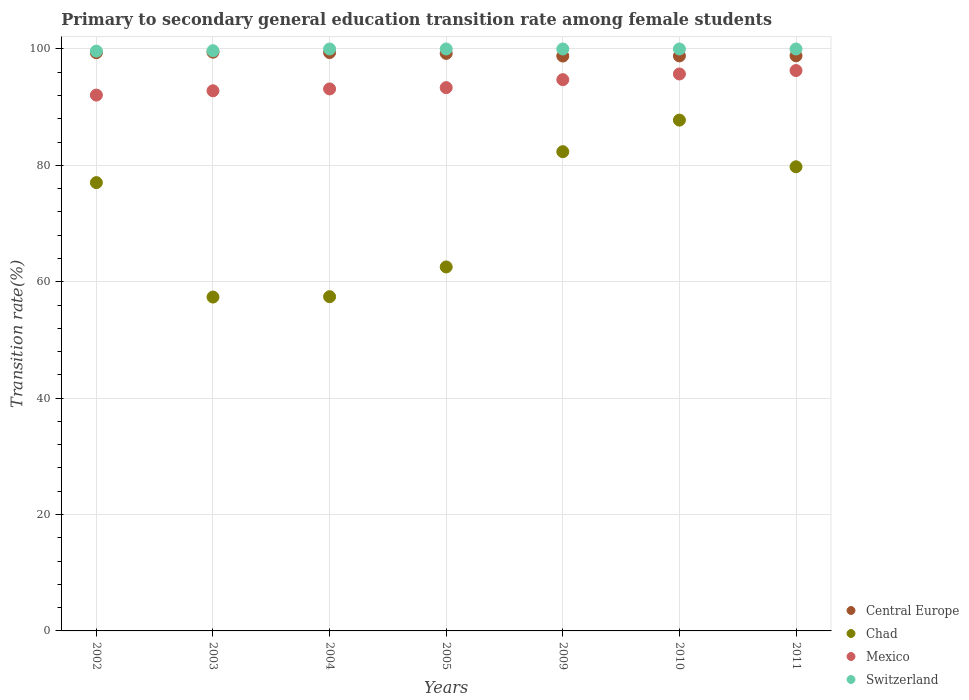Across all years, what is the maximum transition rate in Chad?
Give a very brief answer. 87.78. Across all years, what is the minimum transition rate in Chad?
Provide a succinct answer. 57.37. What is the total transition rate in Mexico in the graph?
Provide a short and direct response. 658.12. What is the difference between the transition rate in Central Europe in 2004 and that in 2010?
Provide a succinct answer. 0.58. What is the difference between the transition rate in Central Europe in 2011 and the transition rate in Switzerland in 2010?
Give a very brief answer. -1.18. What is the average transition rate in Mexico per year?
Provide a succinct answer. 94.02. In the year 2005, what is the difference between the transition rate in Central Europe and transition rate in Switzerland?
Make the answer very short. -0.76. What is the ratio of the transition rate in Chad in 2004 to that in 2005?
Keep it short and to the point. 0.92. Is the transition rate in Central Europe in 2005 less than that in 2010?
Make the answer very short. No. Is the difference between the transition rate in Central Europe in 2003 and 2004 greater than the difference between the transition rate in Switzerland in 2003 and 2004?
Offer a terse response. Yes. What is the difference between the highest and the lowest transition rate in Mexico?
Your response must be concise. 4.22. Is the sum of the transition rate in Switzerland in 2004 and 2011 greater than the maximum transition rate in Central Europe across all years?
Ensure brevity in your answer.  Yes. Is it the case that in every year, the sum of the transition rate in Central Europe and transition rate in Switzerland  is greater than the transition rate in Chad?
Your answer should be compact. Yes. How many dotlines are there?
Ensure brevity in your answer.  4. What is the difference between two consecutive major ticks on the Y-axis?
Offer a terse response. 20. Are the values on the major ticks of Y-axis written in scientific E-notation?
Give a very brief answer. No. Does the graph contain any zero values?
Ensure brevity in your answer.  No. Where does the legend appear in the graph?
Give a very brief answer. Bottom right. How many legend labels are there?
Make the answer very short. 4. How are the legend labels stacked?
Provide a succinct answer. Vertical. What is the title of the graph?
Ensure brevity in your answer.  Primary to secondary general education transition rate among female students. Does "Nepal" appear as one of the legend labels in the graph?
Provide a succinct answer. No. What is the label or title of the X-axis?
Make the answer very short. Years. What is the label or title of the Y-axis?
Give a very brief answer. Transition rate(%). What is the Transition rate(%) of Central Europe in 2002?
Your answer should be very brief. 99.36. What is the Transition rate(%) of Chad in 2002?
Make the answer very short. 77.03. What is the Transition rate(%) of Mexico in 2002?
Your response must be concise. 92.08. What is the Transition rate(%) in Switzerland in 2002?
Provide a short and direct response. 99.64. What is the Transition rate(%) of Central Europe in 2003?
Your answer should be very brief. 99.45. What is the Transition rate(%) of Chad in 2003?
Provide a succinct answer. 57.37. What is the Transition rate(%) of Mexico in 2003?
Your answer should be compact. 92.82. What is the Transition rate(%) in Switzerland in 2003?
Your answer should be compact. 99.7. What is the Transition rate(%) of Central Europe in 2004?
Give a very brief answer. 99.38. What is the Transition rate(%) of Chad in 2004?
Offer a terse response. 57.43. What is the Transition rate(%) of Mexico in 2004?
Offer a very short reply. 93.14. What is the Transition rate(%) of Central Europe in 2005?
Keep it short and to the point. 99.24. What is the Transition rate(%) in Chad in 2005?
Give a very brief answer. 62.54. What is the Transition rate(%) of Mexico in 2005?
Provide a short and direct response. 93.36. What is the Transition rate(%) of Switzerland in 2005?
Your response must be concise. 100. What is the Transition rate(%) in Central Europe in 2009?
Provide a short and direct response. 98.78. What is the Transition rate(%) in Chad in 2009?
Your answer should be compact. 82.35. What is the Transition rate(%) in Mexico in 2009?
Keep it short and to the point. 94.73. What is the Transition rate(%) in Switzerland in 2009?
Your response must be concise. 100. What is the Transition rate(%) in Central Europe in 2010?
Offer a terse response. 98.81. What is the Transition rate(%) in Chad in 2010?
Your answer should be compact. 87.78. What is the Transition rate(%) in Mexico in 2010?
Give a very brief answer. 95.71. What is the Transition rate(%) in Central Europe in 2011?
Keep it short and to the point. 98.82. What is the Transition rate(%) in Chad in 2011?
Keep it short and to the point. 79.76. What is the Transition rate(%) in Mexico in 2011?
Provide a succinct answer. 96.29. What is the Transition rate(%) of Switzerland in 2011?
Your response must be concise. 100. Across all years, what is the maximum Transition rate(%) of Central Europe?
Ensure brevity in your answer.  99.45. Across all years, what is the maximum Transition rate(%) of Chad?
Your response must be concise. 87.78. Across all years, what is the maximum Transition rate(%) in Mexico?
Ensure brevity in your answer.  96.29. Across all years, what is the minimum Transition rate(%) of Central Europe?
Keep it short and to the point. 98.78. Across all years, what is the minimum Transition rate(%) in Chad?
Provide a succinct answer. 57.37. Across all years, what is the minimum Transition rate(%) in Mexico?
Give a very brief answer. 92.08. Across all years, what is the minimum Transition rate(%) of Switzerland?
Your answer should be very brief. 99.64. What is the total Transition rate(%) of Central Europe in the graph?
Keep it short and to the point. 693.85. What is the total Transition rate(%) of Chad in the graph?
Offer a very short reply. 504.27. What is the total Transition rate(%) in Mexico in the graph?
Ensure brevity in your answer.  658.12. What is the total Transition rate(%) in Switzerland in the graph?
Give a very brief answer. 699.34. What is the difference between the Transition rate(%) in Central Europe in 2002 and that in 2003?
Offer a terse response. -0.09. What is the difference between the Transition rate(%) of Chad in 2002 and that in 2003?
Your answer should be compact. 19.66. What is the difference between the Transition rate(%) of Mexico in 2002 and that in 2003?
Make the answer very short. -0.74. What is the difference between the Transition rate(%) in Switzerland in 2002 and that in 2003?
Make the answer very short. -0.07. What is the difference between the Transition rate(%) in Central Europe in 2002 and that in 2004?
Make the answer very short. -0.02. What is the difference between the Transition rate(%) of Chad in 2002 and that in 2004?
Keep it short and to the point. 19.6. What is the difference between the Transition rate(%) of Mexico in 2002 and that in 2004?
Provide a short and direct response. -1.06. What is the difference between the Transition rate(%) of Switzerland in 2002 and that in 2004?
Provide a short and direct response. -0.36. What is the difference between the Transition rate(%) in Central Europe in 2002 and that in 2005?
Make the answer very short. 0.12. What is the difference between the Transition rate(%) in Chad in 2002 and that in 2005?
Ensure brevity in your answer.  14.49. What is the difference between the Transition rate(%) in Mexico in 2002 and that in 2005?
Give a very brief answer. -1.28. What is the difference between the Transition rate(%) of Switzerland in 2002 and that in 2005?
Provide a short and direct response. -0.36. What is the difference between the Transition rate(%) in Central Europe in 2002 and that in 2009?
Offer a terse response. 0.58. What is the difference between the Transition rate(%) of Chad in 2002 and that in 2009?
Offer a terse response. -5.32. What is the difference between the Transition rate(%) in Mexico in 2002 and that in 2009?
Make the answer very short. -2.65. What is the difference between the Transition rate(%) in Switzerland in 2002 and that in 2009?
Your answer should be very brief. -0.36. What is the difference between the Transition rate(%) in Central Europe in 2002 and that in 2010?
Offer a terse response. 0.56. What is the difference between the Transition rate(%) of Chad in 2002 and that in 2010?
Offer a very short reply. -10.74. What is the difference between the Transition rate(%) of Mexico in 2002 and that in 2010?
Keep it short and to the point. -3.63. What is the difference between the Transition rate(%) of Switzerland in 2002 and that in 2010?
Your response must be concise. -0.36. What is the difference between the Transition rate(%) of Central Europe in 2002 and that in 2011?
Your answer should be very brief. 0.54. What is the difference between the Transition rate(%) in Chad in 2002 and that in 2011?
Your answer should be compact. -2.72. What is the difference between the Transition rate(%) in Mexico in 2002 and that in 2011?
Your answer should be very brief. -4.22. What is the difference between the Transition rate(%) in Switzerland in 2002 and that in 2011?
Make the answer very short. -0.36. What is the difference between the Transition rate(%) of Central Europe in 2003 and that in 2004?
Ensure brevity in your answer.  0.07. What is the difference between the Transition rate(%) of Chad in 2003 and that in 2004?
Provide a short and direct response. -0.06. What is the difference between the Transition rate(%) of Mexico in 2003 and that in 2004?
Offer a terse response. -0.32. What is the difference between the Transition rate(%) of Switzerland in 2003 and that in 2004?
Your answer should be compact. -0.3. What is the difference between the Transition rate(%) of Central Europe in 2003 and that in 2005?
Your answer should be very brief. 0.21. What is the difference between the Transition rate(%) of Chad in 2003 and that in 2005?
Your answer should be very brief. -5.17. What is the difference between the Transition rate(%) in Mexico in 2003 and that in 2005?
Your answer should be very brief. -0.54. What is the difference between the Transition rate(%) of Switzerland in 2003 and that in 2005?
Offer a very short reply. -0.3. What is the difference between the Transition rate(%) in Central Europe in 2003 and that in 2009?
Ensure brevity in your answer.  0.67. What is the difference between the Transition rate(%) in Chad in 2003 and that in 2009?
Offer a terse response. -24.98. What is the difference between the Transition rate(%) in Mexico in 2003 and that in 2009?
Offer a terse response. -1.91. What is the difference between the Transition rate(%) of Switzerland in 2003 and that in 2009?
Provide a succinct answer. -0.3. What is the difference between the Transition rate(%) in Central Europe in 2003 and that in 2010?
Keep it short and to the point. 0.65. What is the difference between the Transition rate(%) in Chad in 2003 and that in 2010?
Your response must be concise. -30.41. What is the difference between the Transition rate(%) in Mexico in 2003 and that in 2010?
Offer a very short reply. -2.89. What is the difference between the Transition rate(%) of Switzerland in 2003 and that in 2010?
Keep it short and to the point. -0.3. What is the difference between the Transition rate(%) in Central Europe in 2003 and that in 2011?
Ensure brevity in your answer.  0.63. What is the difference between the Transition rate(%) in Chad in 2003 and that in 2011?
Offer a very short reply. -22.38. What is the difference between the Transition rate(%) of Mexico in 2003 and that in 2011?
Ensure brevity in your answer.  -3.48. What is the difference between the Transition rate(%) in Switzerland in 2003 and that in 2011?
Your answer should be very brief. -0.3. What is the difference between the Transition rate(%) in Central Europe in 2004 and that in 2005?
Your answer should be very brief. 0.14. What is the difference between the Transition rate(%) of Chad in 2004 and that in 2005?
Offer a very short reply. -5.11. What is the difference between the Transition rate(%) of Mexico in 2004 and that in 2005?
Make the answer very short. -0.22. What is the difference between the Transition rate(%) in Central Europe in 2004 and that in 2009?
Give a very brief answer. 0.6. What is the difference between the Transition rate(%) in Chad in 2004 and that in 2009?
Your response must be concise. -24.92. What is the difference between the Transition rate(%) in Mexico in 2004 and that in 2009?
Provide a succinct answer. -1.59. What is the difference between the Transition rate(%) in Switzerland in 2004 and that in 2009?
Your answer should be compact. 0. What is the difference between the Transition rate(%) in Central Europe in 2004 and that in 2010?
Make the answer very short. 0.58. What is the difference between the Transition rate(%) in Chad in 2004 and that in 2010?
Provide a succinct answer. -30.34. What is the difference between the Transition rate(%) of Mexico in 2004 and that in 2010?
Ensure brevity in your answer.  -2.57. What is the difference between the Transition rate(%) of Switzerland in 2004 and that in 2010?
Provide a succinct answer. 0. What is the difference between the Transition rate(%) of Central Europe in 2004 and that in 2011?
Keep it short and to the point. 0.56. What is the difference between the Transition rate(%) of Chad in 2004 and that in 2011?
Make the answer very short. -22.32. What is the difference between the Transition rate(%) in Mexico in 2004 and that in 2011?
Offer a terse response. -3.16. What is the difference between the Transition rate(%) in Central Europe in 2005 and that in 2009?
Your answer should be very brief. 0.46. What is the difference between the Transition rate(%) in Chad in 2005 and that in 2009?
Offer a terse response. -19.81. What is the difference between the Transition rate(%) of Mexico in 2005 and that in 2009?
Give a very brief answer. -1.37. What is the difference between the Transition rate(%) of Central Europe in 2005 and that in 2010?
Provide a short and direct response. 0.44. What is the difference between the Transition rate(%) in Chad in 2005 and that in 2010?
Give a very brief answer. -25.23. What is the difference between the Transition rate(%) in Mexico in 2005 and that in 2010?
Your response must be concise. -2.35. What is the difference between the Transition rate(%) of Central Europe in 2005 and that in 2011?
Offer a terse response. 0.42. What is the difference between the Transition rate(%) of Chad in 2005 and that in 2011?
Give a very brief answer. -17.21. What is the difference between the Transition rate(%) of Mexico in 2005 and that in 2011?
Make the answer very short. -2.94. What is the difference between the Transition rate(%) of Central Europe in 2009 and that in 2010?
Give a very brief answer. -0.02. What is the difference between the Transition rate(%) of Chad in 2009 and that in 2010?
Ensure brevity in your answer.  -5.42. What is the difference between the Transition rate(%) in Mexico in 2009 and that in 2010?
Offer a terse response. -0.98. What is the difference between the Transition rate(%) of Central Europe in 2009 and that in 2011?
Offer a very short reply. -0.04. What is the difference between the Transition rate(%) in Chad in 2009 and that in 2011?
Your response must be concise. 2.6. What is the difference between the Transition rate(%) of Mexico in 2009 and that in 2011?
Provide a short and direct response. -1.56. What is the difference between the Transition rate(%) of Switzerland in 2009 and that in 2011?
Provide a succinct answer. 0. What is the difference between the Transition rate(%) of Central Europe in 2010 and that in 2011?
Your response must be concise. -0.02. What is the difference between the Transition rate(%) of Chad in 2010 and that in 2011?
Provide a short and direct response. 8.02. What is the difference between the Transition rate(%) in Mexico in 2010 and that in 2011?
Your answer should be very brief. -0.59. What is the difference between the Transition rate(%) in Switzerland in 2010 and that in 2011?
Offer a very short reply. 0. What is the difference between the Transition rate(%) in Central Europe in 2002 and the Transition rate(%) in Chad in 2003?
Ensure brevity in your answer.  41.99. What is the difference between the Transition rate(%) in Central Europe in 2002 and the Transition rate(%) in Mexico in 2003?
Provide a succinct answer. 6.55. What is the difference between the Transition rate(%) of Central Europe in 2002 and the Transition rate(%) of Switzerland in 2003?
Your response must be concise. -0.34. What is the difference between the Transition rate(%) in Chad in 2002 and the Transition rate(%) in Mexico in 2003?
Your answer should be compact. -15.78. What is the difference between the Transition rate(%) in Chad in 2002 and the Transition rate(%) in Switzerland in 2003?
Your response must be concise. -22.67. What is the difference between the Transition rate(%) of Mexico in 2002 and the Transition rate(%) of Switzerland in 2003?
Make the answer very short. -7.62. What is the difference between the Transition rate(%) of Central Europe in 2002 and the Transition rate(%) of Chad in 2004?
Offer a terse response. 41.93. What is the difference between the Transition rate(%) in Central Europe in 2002 and the Transition rate(%) in Mexico in 2004?
Provide a short and direct response. 6.23. What is the difference between the Transition rate(%) of Central Europe in 2002 and the Transition rate(%) of Switzerland in 2004?
Ensure brevity in your answer.  -0.64. What is the difference between the Transition rate(%) in Chad in 2002 and the Transition rate(%) in Mexico in 2004?
Offer a terse response. -16.1. What is the difference between the Transition rate(%) of Chad in 2002 and the Transition rate(%) of Switzerland in 2004?
Offer a very short reply. -22.97. What is the difference between the Transition rate(%) in Mexico in 2002 and the Transition rate(%) in Switzerland in 2004?
Offer a terse response. -7.92. What is the difference between the Transition rate(%) in Central Europe in 2002 and the Transition rate(%) in Chad in 2005?
Make the answer very short. 36.82. What is the difference between the Transition rate(%) of Central Europe in 2002 and the Transition rate(%) of Mexico in 2005?
Provide a succinct answer. 6. What is the difference between the Transition rate(%) of Central Europe in 2002 and the Transition rate(%) of Switzerland in 2005?
Provide a succinct answer. -0.64. What is the difference between the Transition rate(%) of Chad in 2002 and the Transition rate(%) of Mexico in 2005?
Your answer should be very brief. -16.32. What is the difference between the Transition rate(%) in Chad in 2002 and the Transition rate(%) in Switzerland in 2005?
Your answer should be compact. -22.97. What is the difference between the Transition rate(%) in Mexico in 2002 and the Transition rate(%) in Switzerland in 2005?
Offer a terse response. -7.92. What is the difference between the Transition rate(%) of Central Europe in 2002 and the Transition rate(%) of Chad in 2009?
Ensure brevity in your answer.  17.01. What is the difference between the Transition rate(%) in Central Europe in 2002 and the Transition rate(%) in Mexico in 2009?
Offer a terse response. 4.63. What is the difference between the Transition rate(%) in Central Europe in 2002 and the Transition rate(%) in Switzerland in 2009?
Offer a very short reply. -0.64. What is the difference between the Transition rate(%) in Chad in 2002 and the Transition rate(%) in Mexico in 2009?
Make the answer very short. -17.69. What is the difference between the Transition rate(%) in Chad in 2002 and the Transition rate(%) in Switzerland in 2009?
Offer a very short reply. -22.97. What is the difference between the Transition rate(%) of Mexico in 2002 and the Transition rate(%) of Switzerland in 2009?
Ensure brevity in your answer.  -7.92. What is the difference between the Transition rate(%) of Central Europe in 2002 and the Transition rate(%) of Chad in 2010?
Offer a terse response. 11.58. What is the difference between the Transition rate(%) in Central Europe in 2002 and the Transition rate(%) in Mexico in 2010?
Ensure brevity in your answer.  3.66. What is the difference between the Transition rate(%) of Central Europe in 2002 and the Transition rate(%) of Switzerland in 2010?
Give a very brief answer. -0.64. What is the difference between the Transition rate(%) of Chad in 2002 and the Transition rate(%) of Mexico in 2010?
Provide a short and direct response. -18.67. What is the difference between the Transition rate(%) of Chad in 2002 and the Transition rate(%) of Switzerland in 2010?
Provide a succinct answer. -22.97. What is the difference between the Transition rate(%) in Mexico in 2002 and the Transition rate(%) in Switzerland in 2010?
Ensure brevity in your answer.  -7.92. What is the difference between the Transition rate(%) in Central Europe in 2002 and the Transition rate(%) in Chad in 2011?
Your answer should be compact. 19.61. What is the difference between the Transition rate(%) in Central Europe in 2002 and the Transition rate(%) in Mexico in 2011?
Offer a very short reply. 3.07. What is the difference between the Transition rate(%) in Central Europe in 2002 and the Transition rate(%) in Switzerland in 2011?
Keep it short and to the point. -0.64. What is the difference between the Transition rate(%) of Chad in 2002 and the Transition rate(%) of Mexico in 2011?
Make the answer very short. -19.26. What is the difference between the Transition rate(%) of Chad in 2002 and the Transition rate(%) of Switzerland in 2011?
Your answer should be compact. -22.97. What is the difference between the Transition rate(%) in Mexico in 2002 and the Transition rate(%) in Switzerland in 2011?
Keep it short and to the point. -7.92. What is the difference between the Transition rate(%) in Central Europe in 2003 and the Transition rate(%) in Chad in 2004?
Ensure brevity in your answer.  42.02. What is the difference between the Transition rate(%) of Central Europe in 2003 and the Transition rate(%) of Mexico in 2004?
Give a very brief answer. 6.32. What is the difference between the Transition rate(%) in Central Europe in 2003 and the Transition rate(%) in Switzerland in 2004?
Offer a terse response. -0.55. What is the difference between the Transition rate(%) in Chad in 2003 and the Transition rate(%) in Mexico in 2004?
Offer a terse response. -35.77. What is the difference between the Transition rate(%) in Chad in 2003 and the Transition rate(%) in Switzerland in 2004?
Offer a very short reply. -42.63. What is the difference between the Transition rate(%) in Mexico in 2003 and the Transition rate(%) in Switzerland in 2004?
Your answer should be compact. -7.18. What is the difference between the Transition rate(%) in Central Europe in 2003 and the Transition rate(%) in Chad in 2005?
Your answer should be compact. 36.91. What is the difference between the Transition rate(%) in Central Europe in 2003 and the Transition rate(%) in Mexico in 2005?
Offer a very short reply. 6.1. What is the difference between the Transition rate(%) of Central Europe in 2003 and the Transition rate(%) of Switzerland in 2005?
Offer a very short reply. -0.55. What is the difference between the Transition rate(%) in Chad in 2003 and the Transition rate(%) in Mexico in 2005?
Make the answer very short. -35.99. What is the difference between the Transition rate(%) in Chad in 2003 and the Transition rate(%) in Switzerland in 2005?
Offer a terse response. -42.63. What is the difference between the Transition rate(%) of Mexico in 2003 and the Transition rate(%) of Switzerland in 2005?
Offer a very short reply. -7.18. What is the difference between the Transition rate(%) of Central Europe in 2003 and the Transition rate(%) of Chad in 2009?
Your answer should be compact. 17.1. What is the difference between the Transition rate(%) in Central Europe in 2003 and the Transition rate(%) in Mexico in 2009?
Give a very brief answer. 4.72. What is the difference between the Transition rate(%) in Central Europe in 2003 and the Transition rate(%) in Switzerland in 2009?
Your response must be concise. -0.55. What is the difference between the Transition rate(%) in Chad in 2003 and the Transition rate(%) in Mexico in 2009?
Give a very brief answer. -37.36. What is the difference between the Transition rate(%) of Chad in 2003 and the Transition rate(%) of Switzerland in 2009?
Offer a terse response. -42.63. What is the difference between the Transition rate(%) in Mexico in 2003 and the Transition rate(%) in Switzerland in 2009?
Ensure brevity in your answer.  -7.18. What is the difference between the Transition rate(%) of Central Europe in 2003 and the Transition rate(%) of Chad in 2010?
Give a very brief answer. 11.68. What is the difference between the Transition rate(%) of Central Europe in 2003 and the Transition rate(%) of Mexico in 2010?
Offer a terse response. 3.75. What is the difference between the Transition rate(%) of Central Europe in 2003 and the Transition rate(%) of Switzerland in 2010?
Ensure brevity in your answer.  -0.55. What is the difference between the Transition rate(%) in Chad in 2003 and the Transition rate(%) in Mexico in 2010?
Offer a terse response. -38.34. What is the difference between the Transition rate(%) in Chad in 2003 and the Transition rate(%) in Switzerland in 2010?
Offer a terse response. -42.63. What is the difference between the Transition rate(%) in Mexico in 2003 and the Transition rate(%) in Switzerland in 2010?
Offer a very short reply. -7.18. What is the difference between the Transition rate(%) in Central Europe in 2003 and the Transition rate(%) in Chad in 2011?
Offer a terse response. 19.7. What is the difference between the Transition rate(%) in Central Europe in 2003 and the Transition rate(%) in Mexico in 2011?
Offer a terse response. 3.16. What is the difference between the Transition rate(%) of Central Europe in 2003 and the Transition rate(%) of Switzerland in 2011?
Give a very brief answer. -0.55. What is the difference between the Transition rate(%) in Chad in 2003 and the Transition rate(%) in Mexico in 2011?
Offer a terse response. -38.92. What is the difference between the Transition rate(%) of Chad in 2003 and the Transition rate(%) of Switzerland in 2011?
Your answer should be very brief. -42.63. What is the difference between the Transition rate(%) in Mexico in 2003 and the Transition rate(%) in Switzerland in 2011?
Offer a terse response. -7.18. What is the difference between the Transition rate(%) of Central Europe in 2004 and the Transition rate(%) of Chad in 2005?
Your response must be concise. 36.84. What is the difference between the Transition rate(%) of Central Europe in 2004 and the Transition rate(%) of Mexico in 2005?
Your response must be concise. 6.02. What is the difference between the Transition rate(%) in Central Europe in 2004 and the Transition rate(%) in Switzerland in 2005?
Your response must be concise. -0.62. What is the difference between the Transition rate(%) of Chad in 2004 and the Transition rate(%) of Mexico in 2005?
Offer a terse response. -35.92. What is the difference between the Transition rate(%) in Chad in 2004 and the Transition rate(%) in Switzerland in 2005?
Ensure brevity in your answer.  -42.57. What is the difference between the Transition rate(%) in Mexico in 2004 and the Transition rate(%) in Switzerland in 2005?
Offer a very short reply. -6.86. What is the difference between the Transition rate(%) in Central Europe in 2004 and the Transition rate(%) in Chad in 2009?
Provide a short and direct response. 17.03. What is the difference between the Transition rate(%) of Central Europe in 2004 and the Transition rate(%) of Mexico in 2009?
Your response must be concise. 4.65. What is the difference between the Transition rate(%) in Central Europe in 2004 and the Transition rate(%) in Switzerland in 2009?
Your answer should be compact. -0.62. What is the difference between the Transition rate(%) in Chad in 2004 and the Transition rate(%) in Mexico in 2009?
Give a very brief answer. -37.3. What is the difference between the Transition rate(%) in Chad in 2004 and the Transition rate(%) in Switzerland in 2009?
Provide a short and direct response. -42.57. What is the difference between the Transition rate(%) in Mexico in 2004 and the Transition rate(%) in Switzerland in 2009?
Your answer should be very brief. -6.86. What is the difference between the Transition rate(%) in Central Europe in 2004 and the Transition rate(%) in Chad in 2010?
Offer a terse response. 11.6. What is the difference between the Transition rate(%) of Central Europe in 2004 and the Transition rate(%) of Mexico in 2010?
Your answer should be very brief. 3.68. What is the difference between the Transition rate(%) of Central Europe in 2004 and the Transition rate(%) of Switzerland in 2010?
Offer a terse response. -0.62. What is the difference between the Transition rate(%) in Chad in 2004 and the Transition rate(%) in Mexico in 2010?
Your answer should be compact. -38.27. What is the difference between the Transition rate(%) in Chad in 2004 and the Transition rate(%) in Switzerland in 2010?
Your answer should be compact. -42.57. What is the difference between the Transition rate(%) in Mexico in 2004 and the Transition rate(%) in Switzerland in 2010?
Your response must be concise. -6.86. What is the difference between the Transition rate(%) of Central Europe in 2004 and the Transition rate(%) of Chad in 2011?
Offer a very short reply. 19.63. What is the difference between the Transition rate(%) of Central Europe in 2004 and the Transition rate(%) of Mexico in 2011?
Make the answer very short. 3.09. What is the difference between the Transition rate(%) of Central Europe in 2004 and the Transition rate(%) of Switzerland in 2011?
Ensure brevity in your answer.  -0.62. What is the difference between the Transition rate(%) in Chad in 2004 and the Transition rate(%) in Mexico in 2011?
Provide a short and direct response. -38.86. What is the difference between the Transition rate(%) in Chad in 2004 and the Transition rate(%) in Switzerland in 2011?
Give a very brief answer. -42.57. What is the difference between the Transition rate(%) of Mexico in 2004 and the Transition rate(%) of Switzerland in 2011?
Ensure brevity in your answer.  -6.86. What is the difference between the Transition rate(%) in Central Europe in 2005 and the Transition rate(%) in Chad in 2009?
Ensure brevity in your answer.  16.89. What is the difference between the Transition rate(%) in Central Europe in 2005 and the Transition rate(%) in Mexico in 2009?
Your answer should be compact. 4.51. What is the difference between the Transition rate(%) in Central Europe in 2005 and the Transition rate(%) in Switzerland in 2009?
Offer a very short reply. -0.76. What is the difference between the Transition rate(%) in Chad in 2005 and the Transition rate(%) in Mexico in 2009?
Make the answer very short. -32.18. What is the difference between the Transition rate(%) of Chad in 2005 and the Transition rate(%) of Switzerland in 2009?
Provide a succinct answer. -37.46. What is the difference between the Transition rate(%) of Mexico in 2005 and the Transition rate(%) of Switzerland in 2009?
Give a very brief answer. -6.64. What is the difference between the Transition rate(%) in Central Europe in 2005 and the Transition rate(%) in Chad in 2010?
Ensure brevity in your answer.  11.46. What is the difference between the Transition rate(%) in Central Europe in 2005 and the Transition rate(%) in Mexico in 2010?
Give a very brief answer. 3.54. What is the difference between the Transition rate(%) of Central Europe in 2005 and the Transition rate(%) of Switzerland in 2010?
Your answer should be very brief. -0.76. What is the difference between the Transition rate(%) in Chad in 2005 and the Transition rate(%) in Mexico in 2010?
Ensure brevity in your answer.  -33.16. What is the difference between the Transition rate(%) of Chad in 2005 and the Transition rate(%) of Switzerland in 2010?
Give a very brief answer. -37.46. What is the difference between the Transition rate(%) of Mexico in 2005 and the Transition rate(%) of Switzerland in 2010?
Provide a succinct answer. -6.64. What is the difference between the Transition rate(%) in Central Europe in 2005 and the Transition rate(%) in Chad in 2011?
Give a very brief answer. 19.49. What is the difference between the Transition rate(%) of Central Europe in 2005 and the Transition rate(%) of Mexico in 2011?
Ensure brevity in your answer.  2.95. What is the difference between the Transition rate(%) of Central Europe in 2005 and the Transition rate(%) of Switzerland in 2011?
Ensure brevity in your answer.  -0.76. What is the difference between the Transition rate(%) of Chad in 2005 and the Transition rate(%) of Mexico in 2011?
Offer a terse response. -33.75. What is the difference between the Transition rate(%) in Chad in 2005 and the Transition rate(%) in Switzerland in 2011?
Offer a very short reply. -37.46. What is the difference between the Transition rate(%) in Mexico in 2005 and the Transition rate(%) in Switzerland in 2011?
Your answer should be compact. -6.64. What is the difference between the Transition rate(%) of Central Europe in 2009 and the Transition rate(%) of Chad in 2010?
Your response must be concise. 11.01. What is the difference between the Transition rate(%) of Central Europe in 2009 and the Transition rate(%) of Mexico in 2010?
Offer a very short reply. 3.08. What is the difference between the Transition rate(%) in Central Europe in 2009 and the Transition rate(%) in Switzerland in 2010?
Offer a very short reply. -1.22. What is the difference between the Transition rate(%) in Chad in 2009 and the Transition rate(%) in Mexico in 2010?
Offer a very short reply. -13.35. What is the difference between the Transition rate(%) in Chad in 2009 and the Transition rate(%) in Switzerland in 2010?
Provide a short and direct response. -17.65. What is the difference between the Transition rate(%) of Mexico in 2009 and the Transition rate(%) of Switzerland in 2010?
Make the answer very short. -5.27. What is the difference between the Transition rate(%) in Central Europe in 2009 and the Transition rate(%) in Chad in 2011?
Make the answer very short. 19.03. What is the difference between the Transition rate(%) of Central Europe in 2009 and the Transition rate(%) of Mexico in 2011?
Your answer should be compact. 2.49. What is the difference between the Transition rate(%) in Central Europe in 2009 and the Transition rate(%) in Switzerland in 2011?
Provide a succinct answer. -1.22. What is the difference between the Transition rate(%) in Chad in 2009 and the Transition rate(%) in Mexico in 2011?
Offer a very short reply. -13.94. What is the difference between the Transition rate(%) of Chad in 2009 and the Transition rate(%) of Switzerland in 2011?
Provide a short and direct response. -17.65. What is the difference between the Transition rate(%) of Mexico in 2009 and the Transition rate(%) of Switzerland in 2011?
Your answer should be very brief. -5.27. What is the difference between the Transition rate(%) of Central Europe in 2010 and the Transition rate(%) of Chad in 2011?
Your response must be concise. 19.05. What is the difference between the Transition rate(%) in Central Europe in 2010 and the Transition rate(%) in Mexico in 2011?
Make the answer very short. 2.51. What is the difference between the Transition rate(%) of Central Europe in 2010 and the Transition rate(%) of Switzerland in 2011?
Ensure brevity in your answer.  -1.19. What is the difference between the Transition rate(%) in Chad in 2010 and the Transition rate(%) in Mexico in 2011?
Provide a short and direct response. -8.52. What is the difference between the Transition rate(%) of Chad in 2010 and the Transition rate(%) of Switzerland in 2011?
Offer a terse response. -12.22. What is the difference between the Transition rate(%) in Mexico in 2010 and the Transition rate(%) in Switzerland in 2011?
Your answer should be very brief. -4.29. What is the average Transition rate(%) in Central Europe per year?
Ensure brevity in your answer.  99.12. What is the average Transition rate(%) of Chad per year?
Offer a terse response. 72.04. What is the average Transition rate(%) of Mexico per year?
Provide a short and direct response. 94.02. What is the average Transition rate(%) of Switzerland per year?
Offer a very short reply. 99.91. In the year 2002, what is the difference between the Transition rate(%) in Central Europe and Transition rate(%) in Chad?
Make the answer very short. 22.33. In the year 2002, what is the difference between the Transition rate(%) of Central Europe and Transition rate(%) of Mexico?
Offer a very short reply. 7.28. In the year 2002, what is the difference between the Transition rate(%) in Central Europe and Transition rate(%) in Switzerland?
Offer a very short reply. -0.27. In the year 2002, what is the difference between the Transition rate(%) of Chad and Transition rate(%) of Mexico?
Your response must be concise. -15.04. In the year 2002, what is the difference between the Transition rate(%) of Chad and Transition rate(%) of Switzerland?
Provide a succinct answer. -22.6. In the year 2002, what is the difference between the Transition rate(%) in Mexico and Transition rate(%) in Switzerland?
Your response must be concise. -7.56. In the year 2003, what is the difference between the Transition rate(%) in Central Europe and Transition rate(%) in Chad?
Ensure brevity in your answer.  42.08. In the year 2003, what is the difference between the Transition rate(%) of Central Europe and Transition rate(%) of Mexico?
Offer a very short reply. 6.64. In the year 2003, what is the difference between the Transition rate(%) in Central Europe and Transition rate(%) in Switzerland?
Keep it short and to the point. -0.25. In the year 2003, what is the difference between the Transition rate(%) in Chad and Transition rate(%) in Mexico?
Your answer should be compact. -35.45. In the year 2003, what is the difference between the Transition rate(%) in Chad and Transition rate(%) in Switzerland?
Provide a succinct answer. -42.33. In the year 2003, what is the difference between the Transition rate(%) of Mexico and Transition rate(%) of Switzerland?
Ensure brevity in your answer.  -6.89. In the year 2004, what is the difference between the Transition rate(%) of Central Europe and Transition rate(%) of Chad?
Make the answer very short. 41.95. In the year 2004, what is the difference between the Transition rate(%) in Central Europe and Transition rate(%) in Mexico?
Provide a succinct answer. 6.25. In the year 2004, what is the difference between the Transition rate(%) of Central Europe and Transition rate(%) of Switzerland?
Your answer should be compact. -0.62. In the year 2004, what is the difference between the Transition rate(%) of Chad and Transition rate(%) of Mexico?
Your answer should be compact. -35.7. In the year 2004, what is the difference between the Transition rate(%) of Chad and Transition rate(%) of Switzerland?
Your response must be concise. -42.57. In the year 2004, what is the difference between the Transition rate(%) in Mexico and Transition rate(%) in Switzerland?
Your response must be concise. -6.86. In the year 2005, what is the difference between the Transition rate(%) of Central Europe and Transition rate(%) of Chad?
Give a very brief answer. 36.7. In the year 2005, what is the difference between the Transition rate(%) in Central Europe and Transition rate(%) in Mexico?
Make the answer very short. 5.88. In the year 2005, what is the difference between the Transition rate(%) in Central Europe and Transition rate(%) in Switzerland?
Offer a very short reply. -0.76. In the year 2005, what is the difference between the Transition rate(%) of Chad and Transition rate(%) of Mexico?
Provide a short and direct response. -30.81. In the year 2005, what is the difference between the Transition rate(%) of Chad and Transition rate(%) of Switzerland?
Your answer should be compact. -37.46. In the year 2005, what is the difference between the Transition rate(%) of Mexico and Transition rate(%) of Switzerland?
Provide a succinct answer. -6.64. In the year 2009, what is the difference between the Transition rate(%) of Central Europe and Transition rate(%) of Chad?
Provide a succinct answer. 16.43. In the year 2009, what is the difference between the Transition rate(%) in Central Europe and Transition rate(%) in Mexico?
Offer a terse response. 4.06. In the year 2009, what is the difference between the Transition rate(%) of Central Europe and Transition rate(%) of Switzerland?
Your answer should be compact. -1.22. In the year 2009, what is the difference between the Transition rate(%) in Chad and Transition rate(%) in Mexico?
Provide a succinct answer. -12.38. In the year 2009, what is the difference between the Transition rate(%) of Chad and Transition rate(%) of Switzerland?
Give a very brief answer. -17.65. In the year 2009, what is the difference between the Transition rate(%) in Mexico and Transition rate(%) in Switzerland?
Your response must be concise. -5.27. In the year 2010, what is the difference between the Transition rate(%) of Central Europe and Transition rate(%) of Chad?
Provide a short and direct response. 11.03. In the year 2010, what is the difference between the Transition rate(%) of Central Europe and Transition rate(%) of Mexico?
Give a very brief answer. 3.1. In the year 2010, what is the difference between the Transition rate(%) of Central Europe and Transition rate(%) of Switzerland?
Your answer should be very brief. -1.19. In the year 2010, what is the difference between the Transition rate(%) of Chad and Transition rate(%) of Mexico?
Provide a short and direct response. -7.93. In the year 2010, what is the difference between the Transition rate(%) of Chad and Transition rate(%) of Switzerland?
Provide a succinct answer. -12.22. In the year 2010, what is the difference between the Transition rate(%) of Mexico and Transition rate(%) of Switzerland?
Provide a short and direct response. -4.29. In the year 2011, what is the difference between the Transition rate(%) of Central Europe and Transition rate(%) of Chad?
Your answer should be very brief. 19.07. In the year 2011, what is the difference between the Transition rate(%) of Central Europe and Transition rate(%) of Mexico?
Keep it short and to the point. 2.53. In the year 2011, what is the difference between the Transition rate(%) of Central Europe and Transition rate(%) of Switzerland?
Offer a terse response. -1.18. In the year 2011, what is the difference between the Transition rate(%) of Chad and Transition rate(%) of Mexico?
Provide a short and direct response. -16.54. In the year 2011, what is the difference between the Transition rate(%) in Chad and Transition rate(%) in Switzerland?
Provide a short and direct response. -20.24. In the year 2011, what is the difference between the Transition rate(%) in Mexico and Transition rate(%) in Switzerland?
Provide a short and direct response. -3.71. What is the ratio of the Transition rate(%) of Chad in 2002 to that in 2003?
Keep it short and to the point. 1.34. What is the ratio of the Transition rate(%) in Mexico in 2002 to that in 2003?
Offer a terse response. 0.99. What is the ratio of the Transition rate(%) in Central Europe in 2002 to that in 2004?
Ensure brevity in your answer.  1. What is the ratio of the Transition rate(%) of Chad in 2002 to that in 2004?
Offer a very short reply. 1.34. What is the ratio of the Transition rate(%) in Chad in 2002 to that in 2005?
Your answer should be compact. 1.23. What is the ratio of the Transition rate(%) of Mexico in 2002 to that in 2005?
Ensure brevity in your answer.  0.99. What is the ratio of the Transition rate(%) of Switzerland in 2002 to that in 2005?
Offer a terse response. 1. What is the ratio of the Transition rate(%) of Chad in 2002 to that in 2009?
Offer a terse response. 0.94. What is the ratio of the Transition rate(%) of Central Europe in 2002 to that in 2010?
Ensure brevity in your answer.  1.01. What is the ratio of the Transition rate(%) of Chad in 2002 to that in 2010?
Give a very brief answer. 0.88. What is the ratio of the Transition rate(%) of Mexico in 2002 to that in 2010?
Offer a terse response. 0.96. What is the ratio of the Transition rate(%) of Switzerland in 2002 to that in 2010?
Keep it short and to the point. 1. What is the ratio of the Transition rate(%) of Central Europe in 2002 to that in 2011?
Your answer should be compact. 1.01. What is the ratio of the Transition rate(%) of Chad in 2002 to that in 2011?
Offer a terse response. 0.97. What is the ratio of the Transition rate(%) in Mexico in 2002 to that in 2011?
Make the answer very short. 0.96. What is the ratio of the Transition rate(%) of Switzerland in 2002 to that in 2011?
Offer a very short reply. 1. What is the ratio of the Transition rate(%) in Mexico in 2003 to that in 2004?
Ensure brevity in your answer.  1. What is the ratio of the Transition rate(%) in Central Europe in 2003 to that in 2005?
Offer a very short reply. 1. What is the ratio of the Transition rate(%) of Chad in 2003 to that in 2005?
Your response must be concise. 0.92. What is the ratio of the Transition rate(%) in Mexico in 2003 to that in 2005?
Ensure brevity in your answer.  0.99. What is the ratio of the Transition rate(%) of Central Europe in 2003 to that in 2009?
Your answer should be compact. 1.01. What is the ratio of the Transition rate(%) of Chad in 2003 to that in 2009?
Provide a short and direct response. 0.7. What is the ratio of the Transition rate(%) in Mexico in 2003 to that in 2009?
Provide a short and direct response. 0.98. What is the ratio of the Transition rate(%) of Central Europe in 2003 to that in 2010?
Give a very brief answer. 1.01. What is the ratio of the Transition rate(%) in Chad in 2003 to that in 2010?
Make the answer very short. 0.65. What is the ratio of the Transition rate(%) of Mexico in 2003 to that in 2010?
Provide a succinct answer. 0.97. What is the ratio of the Transition rate(%) of Switzerland in 2003 to that in 2010?
Offer a terse response. 1. What is the ratio of the Transition rate(%) of Central Europe in 2003 to that in 2011?
Offer a very short reply. 1.01. What is the ratio of the Transition rate(%) in Chad in 2003 to that in 2011?
Provide a succinct answer. 0.72. What is the ratio of the Transition rate(%) of Mexico in 2003 to that in 2011?
Give a very brief answer. 0.96. What is the ratio of the Transition rate(%) in Switzerland in 2003 to that in 2011?
Provide a succinct answer. 1. What is the ratio of the Transition rate(%) in Chad in 2004 to that in 2005?
Ensure brevity in your answer.  0.92. What is the ratio of the Transition rate(%) in Mexico in 2004 to that in 2005?
Provide a succinct answer. 1. What is the ratio of the Transition rate(%) of Chad in 2004 to that in 2009?
Your answer should be very brief. 0.7. What is the ratio of the Transition rate(%) in Mexico in 2004 to that in 2009?
Offer a very short reply. 0.98. What is the ratio of the Transition rate(%) in Chad in 2004 to that in 2010?
Your answer should be very brief. 0.65. What is the ratio of the Transition rate(%) of Mexico in 2004 to that in 2010?
Keep it short and to the point. 0.97. What is the ratio of the Transition rate(%) in Switzerland in 2004 to that in 2010?
Offer a terse response. 1. What is the ratio of the Transition rate(%) in Central Europe in 2004 to that in 2011?
Keep it short and to the point. 1.01. What is the ratio of the Transition rate(%) in Chad in 2004 to that in 2011?
Offer a terse response. 0.72. What is the ratio of the Transition rate(%) of Mexico in 2004 to that in 2011?
Offer a terse response. 0.97. What is the ratio of the Transition rate(%) in Central Europe in 2005 to that in 2009?
Make the answer very short. 1. What is the ratio of the Transition rate(%) of Chad in 2005 to that in 2009?
Provide a short and direct response. 0.76. What is the ratio of the Transition rate(%) in Mexico in 2005 to that in 2009?
Ensure brevity in your answer.  0.99. What is the ratio of the Transition rate(%) of Central Europe in 2005 to that in 2010?
Ensure brevity in your answer.  1. What is the ratio of the Transition rate(%) of Chad in 2005 to that in 2010?
Provide a succinct answer. 0.71. What is the ratio of the Transition rate(%) in Mexico in 2005 to that in 2010?
Make the answer very short. 0.98. What is the ratio of the Transition rate(%) in Central Europe in 2005 to that in 2011?
Offer a very short reply. 1. What is the ratio of the Transition rate(%) of Chad in 2005 to that in 2011?
Provide a succinct answer. 0.78. What is the ratio of the Transition rate(%) in Mexico in 2005 to that in 2011?
Your answer should be very brief. 0.97. What is the ratio of the Transition rate(%) in Switzerland in 2005 to that in 2011?
Make the answer very short. 1. What is the ratio of the Transition rate(%) in Chad in 2009 to that in 2010?
Provide a succinct answer. 0.94. What is the ratio of the Transition rate(%) in Switzerland in 2009 to that in 2010?
Ensure brevity in your answer.  1. What is the ratio of the Transition rate(%) of Chad in 2009 to that in 2011?
Provide a short and direct response. 1.03. What is the ratio of the Transition rate(%) of Mexico in 2009 to that in 2011?
Your answer should be compact. 0.98. What is the ratio of the Transition rate(%) of Chad in 2010 to that in 2011?
Offer a terse response. 1.1. What is the ratio of the Transition rate(%) in Mexico in 2010 to that in 2011?
Make the answer very short. 0.99. What is the ratio of the Transition rate(%) of Switzerland in 2010 to that in 2011?
Keep it short and to the point. 1. What is the difference between the highest and the second highest Transition rate(%) of Central Europe?
Your answer should be compact. 0.07. What is the difference between the highest and the second highest Transition rate(%) in Chad?
Provide a succinct answer. 5.42. What is the difference between the highest and the second highest Transition rate(%) in Mexico?
Your response must be concise. 0.59. What is the difference between the highest and the second highest Transition rate(%) of Switzerland?
Your answer should be very brief. 0. What is the difference between the highest and the lowest Transition rate(%) of Central Europe?
Ensure brevity in your answer.  0.67. What is the difference between the highest and the lowest Transition rate(%) of Chad?
Offer a very short reply. 30.41. What is the difference between the highest and the lowest Transition rate(%) of Mexico?
Give a very brief answer. 4.22. What is the difference between the highest and the lowest Transition rate(%) in Switzerland?
Make the answer very short. 0.36. 